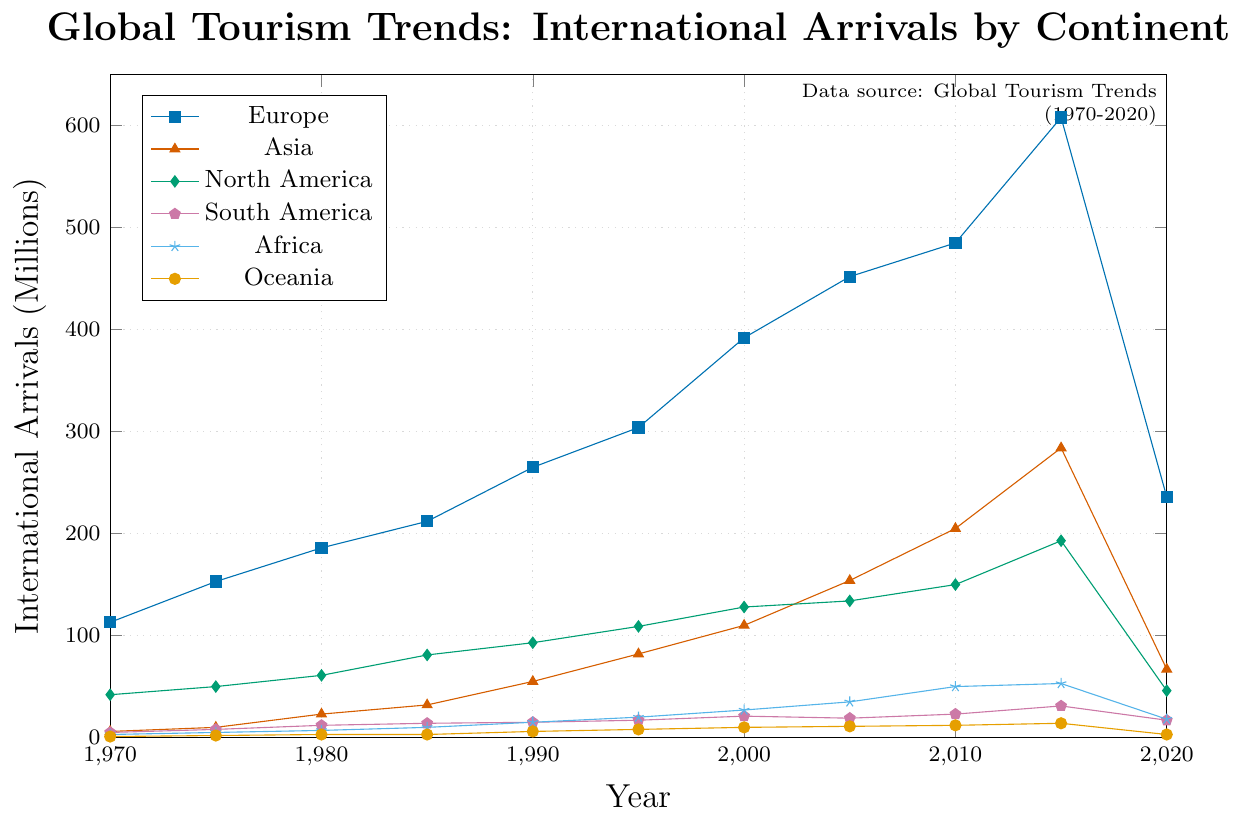What was the trend for Europe from 1970 to 2015? The arrivals in Europe increase steadily from 113 million in 1970 to 608 million in 2015. Each interval shows significant growth without any declines during this period.
Answer: Steady increase Which continent saw the largest drop in arrivals in 2020 compared to 2015? Europe had the largest drop from 608 million in 2015 to 236 million in 2020, which is a reduction of 372 million.
Answer: Europe By how many millions did tourism arrivals in Asia increase from 1970 to 2015? In 1970, Asia had 6 million arrivals, and this number increased to 284 million in 2015. The difference is 284 - 6 = 278 million.
Answer: 278 million During which decade did Africa see the most significant increase in tourism arrivals? Between 2000 and 2010, Africa's arrivals increased from 27 million to 50 million, an increase of 23 million. This is the largest increase in a decade compared to other periods.
Answer: 2000-2010 Which two continents had nearly equal tourism arrivals in 2020? In 2020, both South America and Africa had similar arrivals, with South America at 17 million and Africa at 18 million.
Answer: South America and Africa How many total international arrivals were there in North America and Asia in 1995? North America had 109 million arrivals and Asia had 82 million arrivals in 1995. The total is 109 + 82 = 191 million.
Answer: 191 million What was the growth rate of international arrivals for Oceania from 1980 to 1990? Oceania had 3 million arrivals in 1980 and 6 million in 1990. The growth rate is calculated by (6 - 3) / 3 * 100 = 100%.
Answer: 100% Which year saw the highest number of international arrivals in Europe? 2015 had the highest number of international arrivals in Europe, with 608 million.
Answer: 2015 What is the average number of international arrivals in South America across all the years provided? The total international arrivals for South America across the years (5, 8, 12, 14, 15, 17, 21, 19, 23, 31, 17) add up to 182 million. Dividing by 11 years, the average is 182 / 11 ≈ 16.55 million.
Answer: 16.55 million 